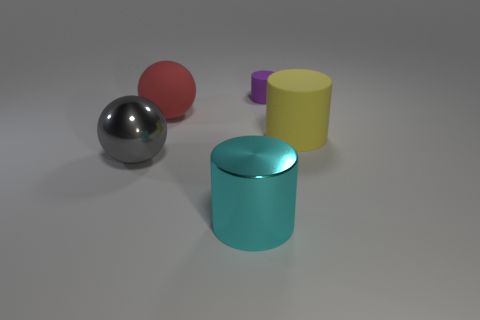Subtract all purple rubber cylinders. How many cylinders are left? 2 Add 1 small matte cylinders. How many objects exist? 6 Subtract all gray balls. How many balls are left? 1 Subtract all balls. How many objects are left? 3 Add 1 small gray objects. How many small gray objects exist? 1 Subtract 1 purple cylinders. How many objects are left? 4 Subtract all red cylinders. Subtract all green blocks. How many cylinders are left? 3 Subtract all gray metal spheres. Subtract all large gray metal things. How many objects are left? 3 Add 5 yellow objects. How many yellow objects are left? 6 